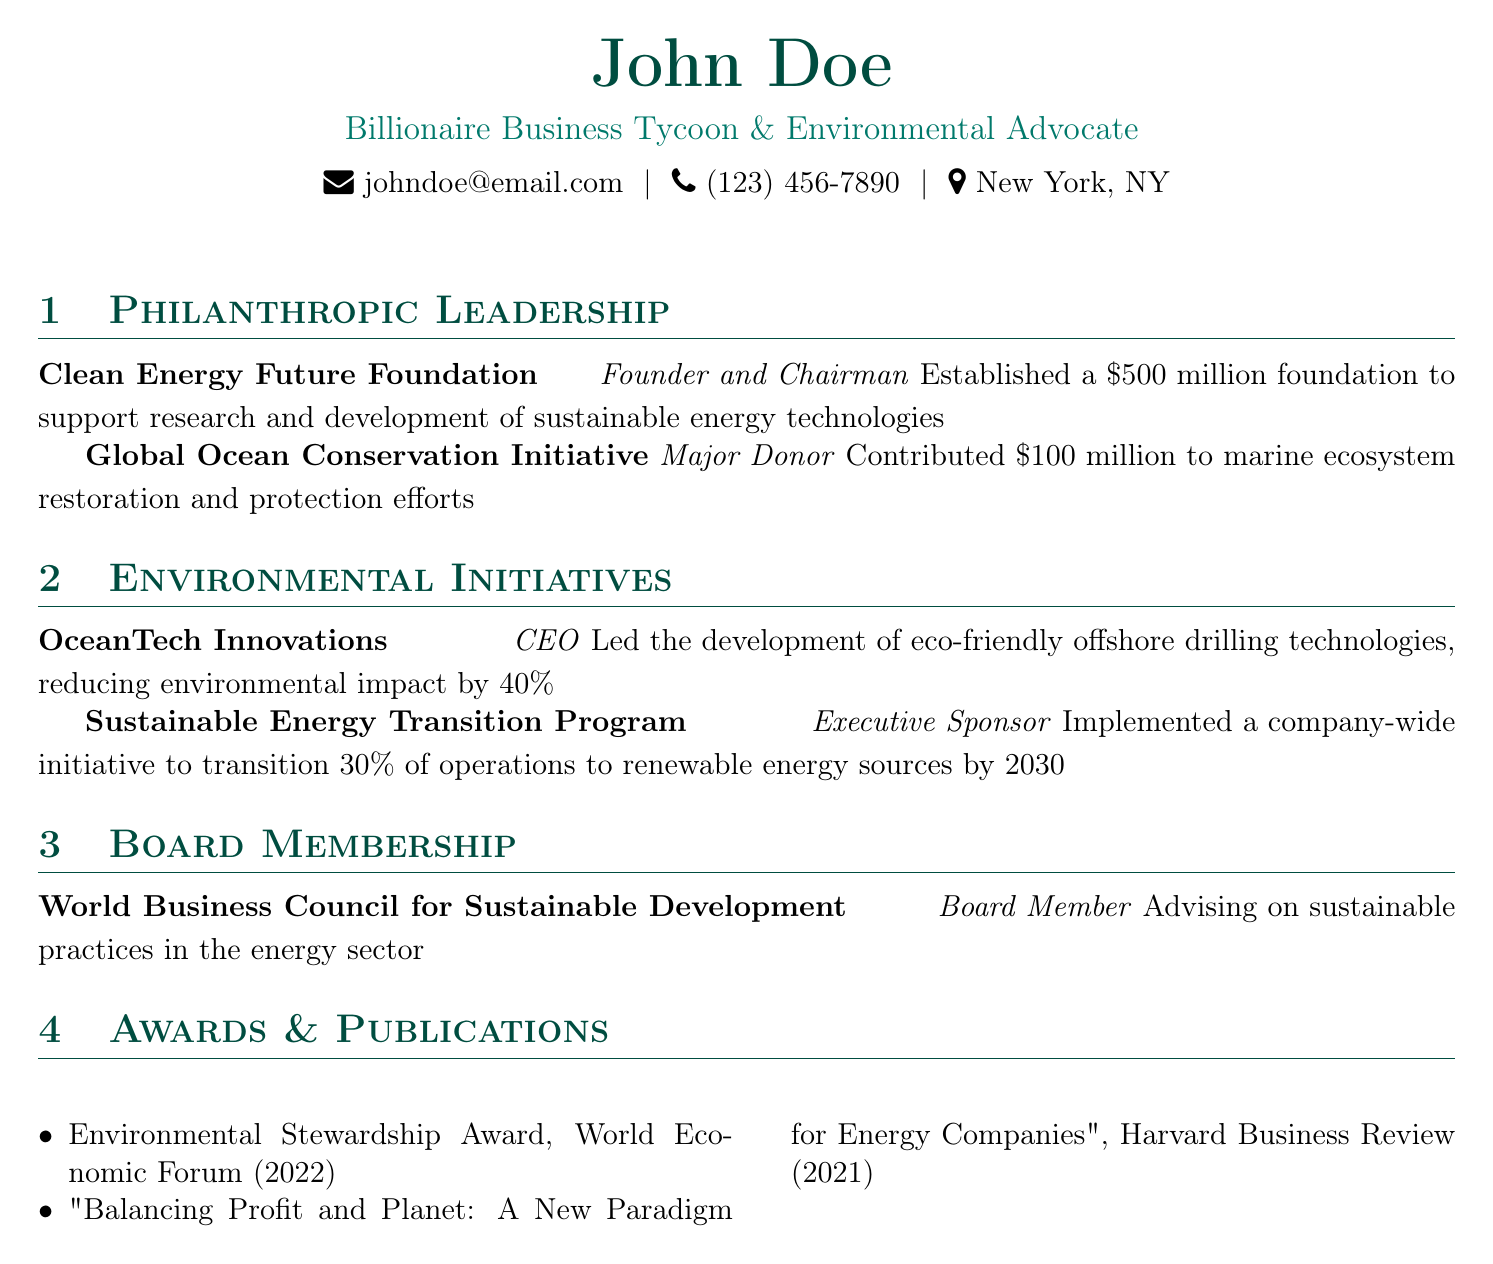What is the name of the foundation established? The foundation established is the Clean Energy Future Foundation.
Answer: Clean Energy Future Foundation How much was contributed to the Global Ocean Conservation Initiative? The contribution to the Global Ocean Conservation Initiative was $100 million.
Answer: $100 million What percentage of operations is the Sustainable Energy Transition Program targeting to transition to renewable sources by 2030? The initiative targets to transition 30% of operations to renewable energy sources by 2030.
Answer: 30% In which year did John Doe receive the Environmental Stewardship Award? The Environmental Stewardship Award was received in 2022.
Answer: 2022 What role does John Doe hold at OceanTech Innovations? John Doe is the CEO of OceanTech Innovations.
Answer: CEO What is the title of the publication authored by John Doe? The title of the publication is "Balancing Profit and Planet: A New Paradigm for Energy Companies".
Answer: Balancing Profit and Planet: A New Paradigm for Energy Companies How much funding was established for the Clean Energy Future Foundation? The funding established for the foundation was $500 million.
Answer: $500 million What organization is John Doe a board member of? John Doe is a board member of the World Business Council for Sustainable Development.
Answer: World Business Council for Sustainable Development 